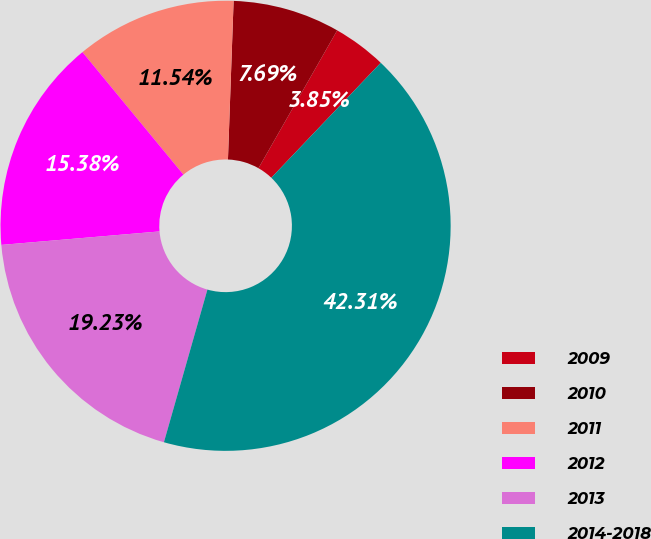<chart> <loc_0><loc_0><loc_500><loc_500><pie_chart><fcel>2009<fcel>2010<fcel>2011<fcel>2012<fcel>2013<fcel>2014-2018<nl><fcel>3.85%<fcel>7.69%<fcel>11.54%<fcel>15.38%<fcel>19.23%<fcel>42.31%<nl></chart> 